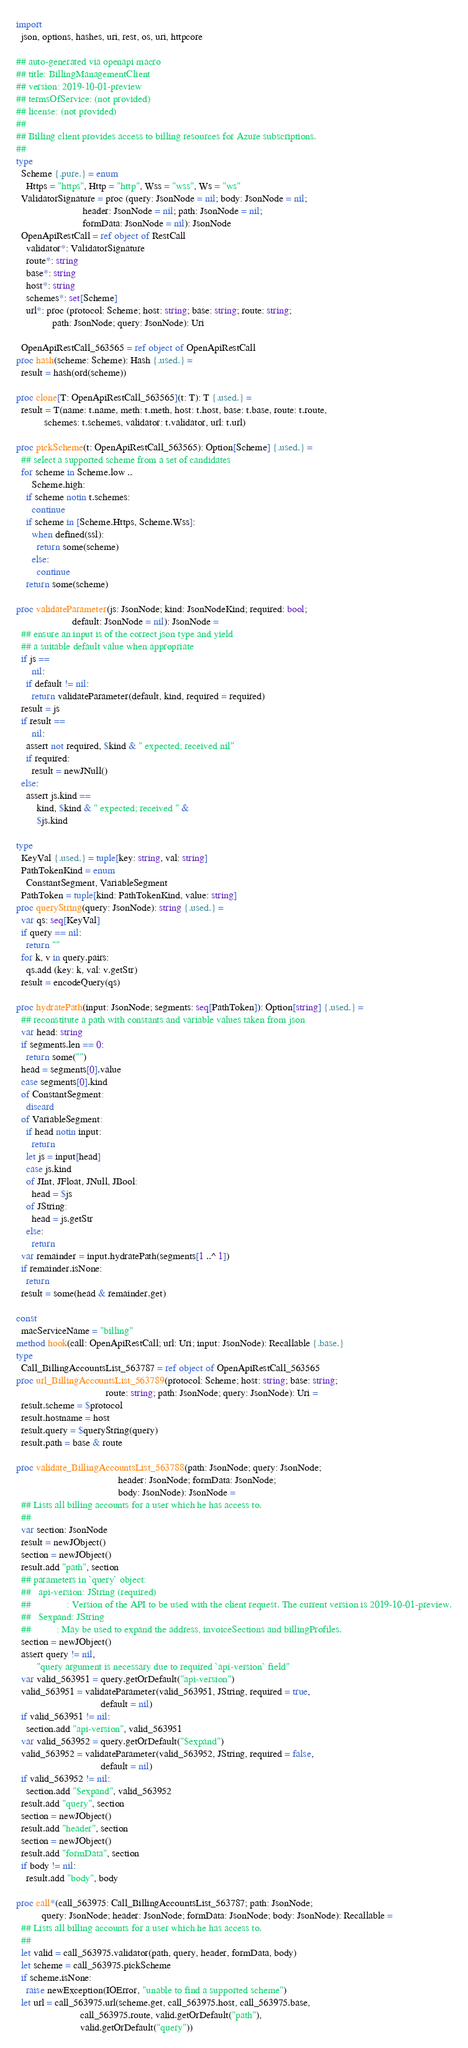Convert code to text. <code><loc_0><loc_0><loc_500><loc_500><_Nim_>
import
  json, options, hashes, uri, rest, os, uri, httpcore

## auto-generated via openapi macro
## title: BillingManagementClient
## version: 2019-10-01-preview
## termsOfService: (not provided)
## license: (not provided)
## 
## Billing client provides access to billing resources for Azure subscriptions.
## 
type
  Scheme {.pure.} = enum
    Https = "https", Http = "http", Wss = "wss", Ws = "ws"
  ValidatorSignature = proc (query: JsonNode = nil; body: JsonNode = nil;
                          header: JsonNode = nil; path: JsonNode = nil;
                          formData: JsonNode = nil): JsonNode
  OpenApiRestCall = ref object of RestCall
    validator*: ValidatorSignature
    route*: string
    base*: string
    host*: string
    schemes*: set[Scheme]
    url*: proc (protocol: Scheme; host: string; base: string; route: string;
              path: JsonNode; query: JsonNode): Uri

  OpenApiRestCall_563565 = ref object of OpenApiRestCall
proc hash(scheme: Scheme): Hash {.used.} =
  result = hash(ord(scheme))

proc clone[T: OpenApiRestCall_563565](t: T): T {.used.} =
  result = T(name: t.name, meth: t.meth, host: t.host, base: t.base, route: t.route,
           schemes: t.schemes, validator: t.validator, url: t.url)

proc pickScheme(t: OpenApiRestCall_563565): Option[Scheme] {.used.} =
  ## select a supported scheme from a set of candidates
  for scheme in Scheme.low ..
      Scheme.high:
    if scheme notin t.schemes:
      continue
    if scheme in [Scheme.Https, Scheme.Wss]:
      when defined(ssl):
        return some(scheme)
      else:
        continue
    return some(scheme)

proc validateParameter(js: JsonNode; kind: JsonNodeKind; required: bool;
                      default: JsonNode = nil): JsonNode =
  ## ensure an input is of the correct json type and yield
  ## a suitable default value when appropriate
  if js ==
      nil:
    if default != nil:
      return validateParameter(default, kind, required = required)
  result = js
  if result ==
      nil:
    assert not required, $kind & " expected; received nil"
    if required:
      result = newJNull()
  else:
    assert js.kind ==
        kind, $kind & " expected; received " &
        $js.kind

type
  KeyVal {.used.} = tuple[key: string, val: string]
  PathTokenKind = enum
    ConstantSegment, VariableSegment
  PathToken = tuple[kind: PathTokenKind, value: string]
proc queryString(query: JsonNode): string {.used.} =
  var qs: seq[KeyVal]
  if query == nil:
    return ""
  for k, v in query.pairs:
    qs.add (key: k, val: v.getStr)
  result = encodeQuery(qs)

proc hydratePath(input: JsonNode; segments: seq[PathToken]): Option[string] {.used.} =
  ## reconstitute a path with constants and variable values taken from json
  var head: string
  if segments.len == 0:
    return some("")
  head = segments[0].value
  case segments[0].kind
  of ConstantSegment:
    discard
  of VariableSegment:
    if head notin input:
      return
    let js = input[head]
    case js.kind
    of JInt, JFloat, JNull, JBool:
      head = $js
    of JString:
      head = js.getStr
    else:
      return
  var remainder = input.hydratePath(segments[1 ..^ 1])
  if remainder.isNone:
    return
  result = some(head & remainder.get)

const
  macServiceName = "billing"
method hook(call: OpenApiRestCall; url: Uri; input: JsonNode): Recallable {.base.}
type
  Call_BillingAccountsList_563787 = ref object of OpenApiRestCall_563565
proc url_BillingAccountsList_563789(protocol: Scheme; host: string; base: string;
                                   route: string; path: JsonNode; query: JsonNode): Uri =
  result.scheme = $protocol
  result.hostname = host
  result.query = $queryString(query)
  result.path = base & route

proc validate_BillingAccountsList_563788(path: JsonNode; query: JsonNode;
                                        header: JsonNode; formData: JsonNode;
                                        body: JsonNode): JsonNode =
  ## Lists all billing accounts for a user which he has access to.
  ## 
  var section: JsonNode
  result = newJObject()
  section = newJObject()
  result.add "path", section
  ## parameters in `query` object:
  ##   api-version: JString (required)
  ##              : Version of the API to be used with the client request. The current version is 2019-10-01-preview.
  ##   $expand: JString
  ##          : May be used to expand the address, invoiceSections and billingProfiles.
  section = newJObject()
  assert query != nil,
        "query argument is necessary due to required `api-version` field"
  var valid_563951 = query.getOrDefault("api-version")
  valid_563951 = validateParameter(valid_563951, JString, required = true,
                                 default = nil)
  if valid_563951 != nil:
    section.add "api-version", valid_563951
  var valid_563952 = query.getOrDefault("$expand")
  valid_563952 = validateParameter(valid_563952, JString, required = false,
                                 default = nil)
  if valid_563952 != nil:
    section.add "$expand", valid_563952
  result.add "query", section
  section = newJObject()
  result.add "header", section
  section = newJObject()
  result.add "formData", section
  if body != nil:
    result.add "body", body

proc call*(call_563975: Call_BillingAccountsList_563787; path: JsonNode;
          query: JsonNode; header: JsonNode; formData: JsonNode; body: JsonNode): Recallable =
  ## Lists all billing accounts for a user which he has access to.
  ## 
  let valid = call_563975.validator(path, query, header, formData, body)
  let scheme = call_563975.pickScheme
  if scheme.isNone:
    raise newException(IOError, "unable to find a supported scheme")
  let url = call_563975.url(scheme.get, call_563975.host, call_563975.base,
                         call_563975.route, valid.getOrDefault("path"),
                         valid.getOrDefault("query"))</code> 